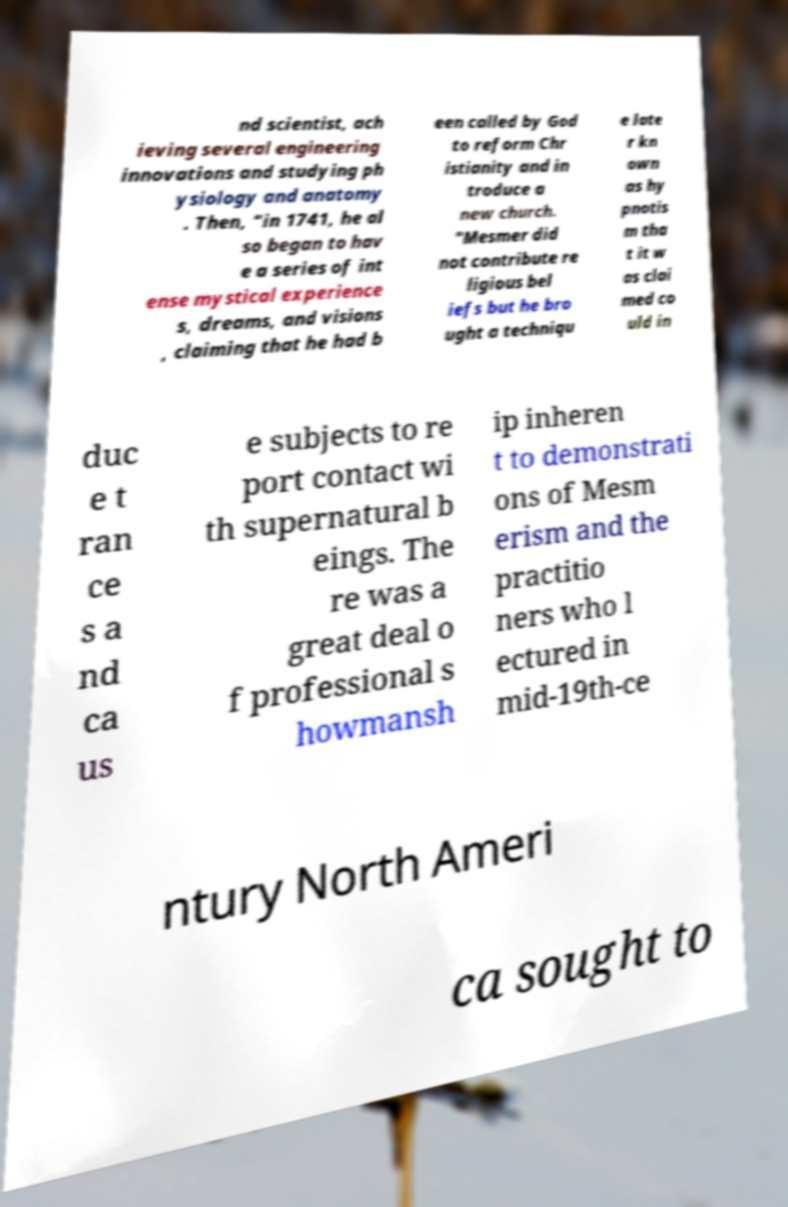For documentation purposes, I need the text within this image transcribed. Could you provide that? nd scientist, ach ieving several engineering innovations and studying ph ysiology and anatomy . Then, “in 1741, he al so began to hav e a series of int ense mystical experience s, dreams, and visions , claiming that he had b een called by God to reform Chr istianity and in troduce a new church. "Mesmer did not contribute re ligious bel iefs but he bro ught a techniqu e late r kn own as hy pnotis m tha t it w as clai med co uld in duc e t ran ce s a nd ca us e subjects to re port contact wi th supernatural b eings. The re was a great deal o f professional s howmansh ip inheren t to demonstrati ons of Mesm erism and the practitio ners who l ectured in mid-19th-ce ntury North Ameri ca sought to 